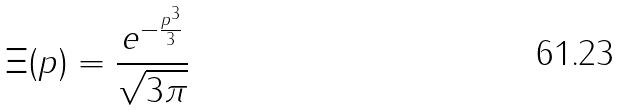<formula> <loc_0><loc_0><loc_500><loc_500>\Xi ( p ) = \frac { e ^ { - \frac { p ^ { 3 } } { 3 } } } { \sqrt { 3 \pi } }</formula> 